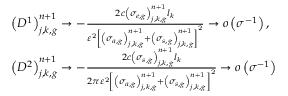<formula> <loc_0><loc_0><loc_500><loc_500>\begin{array} { l } { { \left ( D ^ { 1 } \right ) _ { j , k , g } ^ { n + 1 } \to - \frac { 2 c \left ( \sigma _ { e , g } \right ) _ { j , k , g } ^ { n + 1 } l _ { k } } { \varepsilon ^ { 2 } \left [ \left ( \sigma _ { a , g } \right ) _ { j , k , g } ^ { n + 1 } + \left ( \sigma _ { s , g } \right ) _ { j , k , g } ^ { n + 1 } \right ] ^ { 2 } } \to o \left ( \sigma ^ { - 1 } \right ) , } } \\ { { \left ( D ^ { 2 } \right ) _ { j , k , g } ^ { n + 1 } \to - \frac { 2 c \left ( \sigma _ { s , g } \right ) _ { j , k , g } ^ { n + 1 } l _ { k } } { 2 \pi \varepsilon ^ { 2 } \left [ \left ( \sigma _ { a , g } \right ) _ { j , k , g } ^ { n + 1 } + \left ( \sigma _ { s , g } \right ) _ { j , k , g } ^ { n + 1 } \right ] ^ { 2 } } \to o \left ( \sigma ^ { - 1 } \right ) } } \end{array}</formula> 